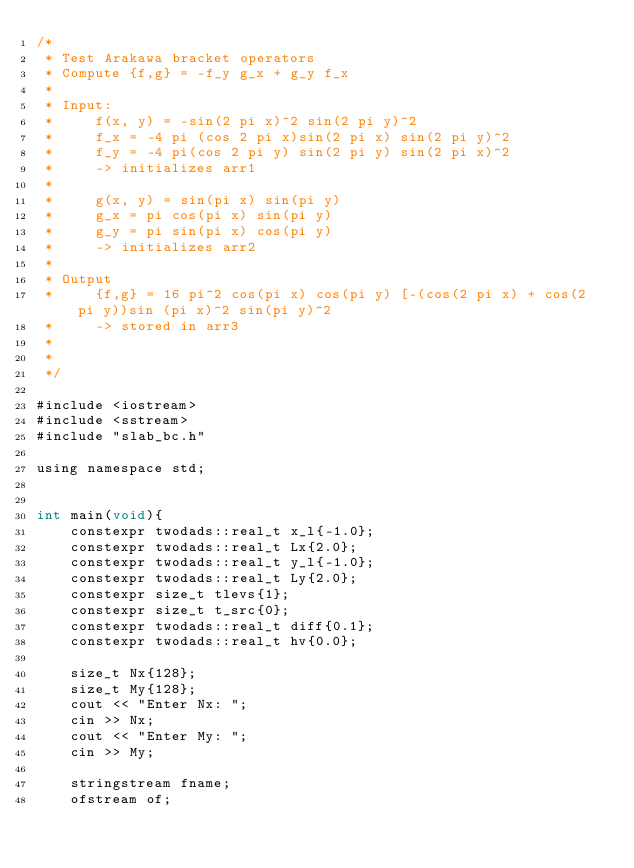<code> <loc_0><loc_0><loc_500><loc_500><_Cuda_>/*
 * Test Arakawa bracket operators
 * Compute {f,g} = -f_y g_x + g_y f_x
 * 
 * Input:
 *     f(x, y) = -sin(2 pi x)^2 sin(2 pi y)^2
 *     f_x = -4 pi (cos 2 pi x)sin(2 pi x) sin(2 pi y)^2
 *     f_y = -4 pi(cos 2 pi y) sin(2 pi y) sin(2 pi x)^2
 *     -> initializes arr1
 * 
 *     g(x, y) = sin(pi x) sin(pi y)
 *     g_x = pi cos(pi x) sin(pi y)
 *     g_y = pi sin(pi x) cos(pi y)
 *     -> initializes arr2
 *
 * Output
 *     {f,g} = 16 pi^2 cos(pi x) cos(pi y) [-(cos(2 pi x) + cos(2 pi y))sin (pi x)^2 sin(pi y)^2
 *     -> stored in arr3
 *
 *
 */

#include <iostream>
#include <sstream>
#include "slab_bc.h"

using namespace std;


int main(void){
    constexpr twodads::real_t x_l{-1.0};
    constexpr twodads::real_t Lx{2.0};
    constexpr twodads::real_t y_l{-1.0};
    constexpr twodads::real_t Ly{2.0};
    constexpr size_t tlevs{1};
    constexpr size_t t_src{0};
    constexpr twodads::real_t diff{0.1};
    constexpr twodads::real_t hv{0.0};

    size_t Nx{128};
    size_t My{128};
    cout << "Enter Nx: ";
    cin >> Nx;
    cout << "Enter My: ";
    cin >> My;

    stringstream fname;
    ofstream of;
</code> 